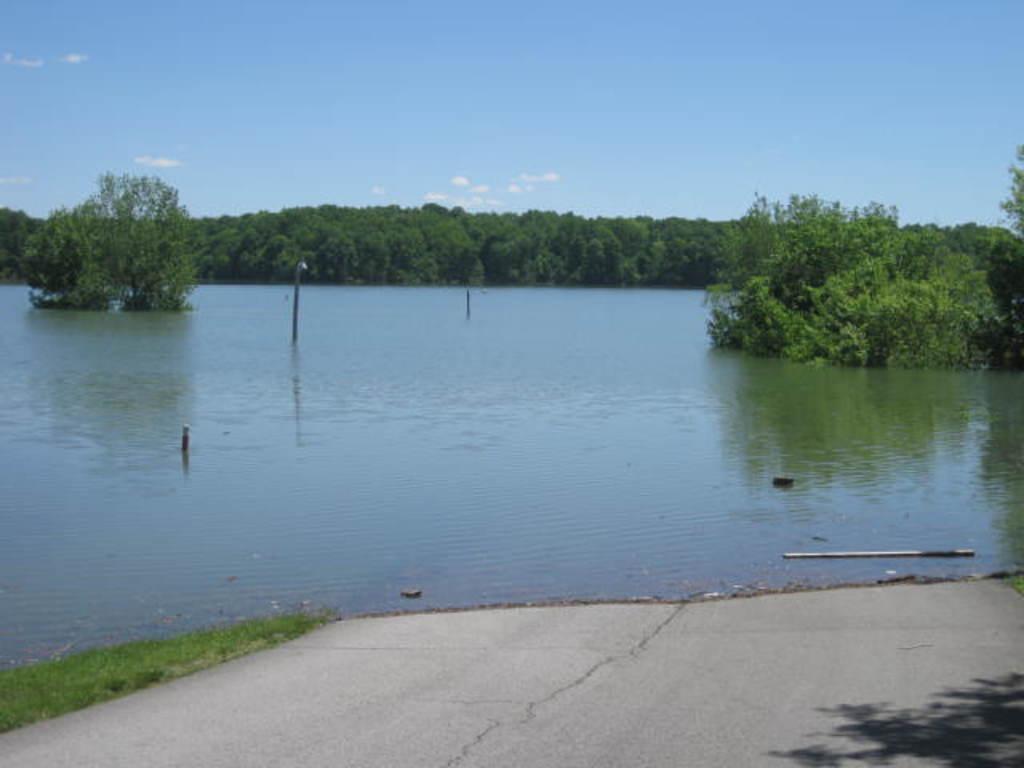Could you give a brief overview of what you see in this image? In this image we can see a lake with some poles inside it. We can also see some plants, grass, trees and the sky which looks cloudy. 